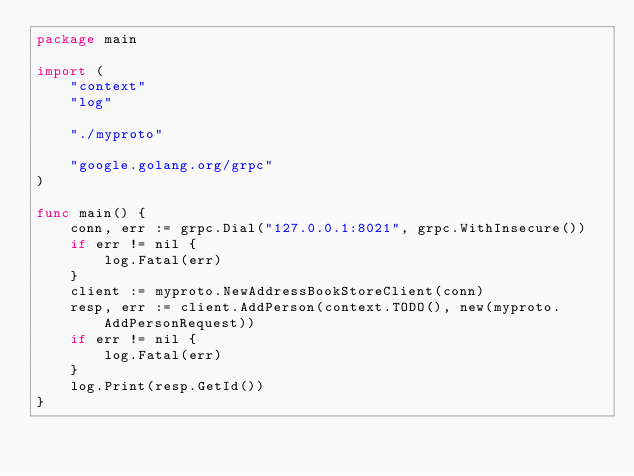Convert code to text. <code><loc_0><loc_0><loc_500><loc_500><_Go_>package main

import (
	"context"
	"log"

	"./myproto"

	"google.golang.org/grpc"
)

func main() {
	conn, err := grpc.Dial("127.0.0.1:8021", grpc.WithInsecure())
	if err != nil {
		log.Fatal(err)
	}
	client := myproto.NewAddressBookStoreClient(conn)
	resp, err := client.AddPerson(context.TODO(), new(myproto.AddPersonRequest))
	if err != nil {
		log.Fatal(err)
	}
	log.Print(resp.GetId())
}
</code> 